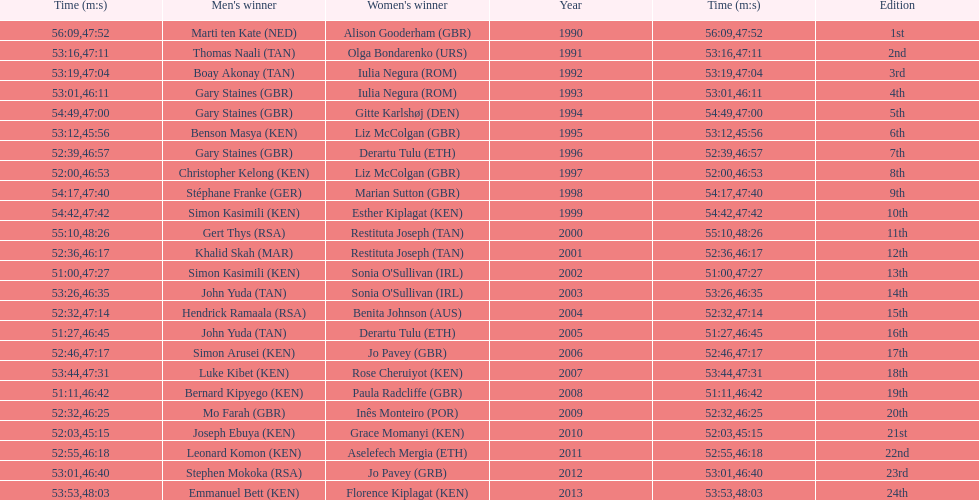What is the number of times, between 1990 and 2013, for britain not to win the men's or women's bupa great south run? 13. 